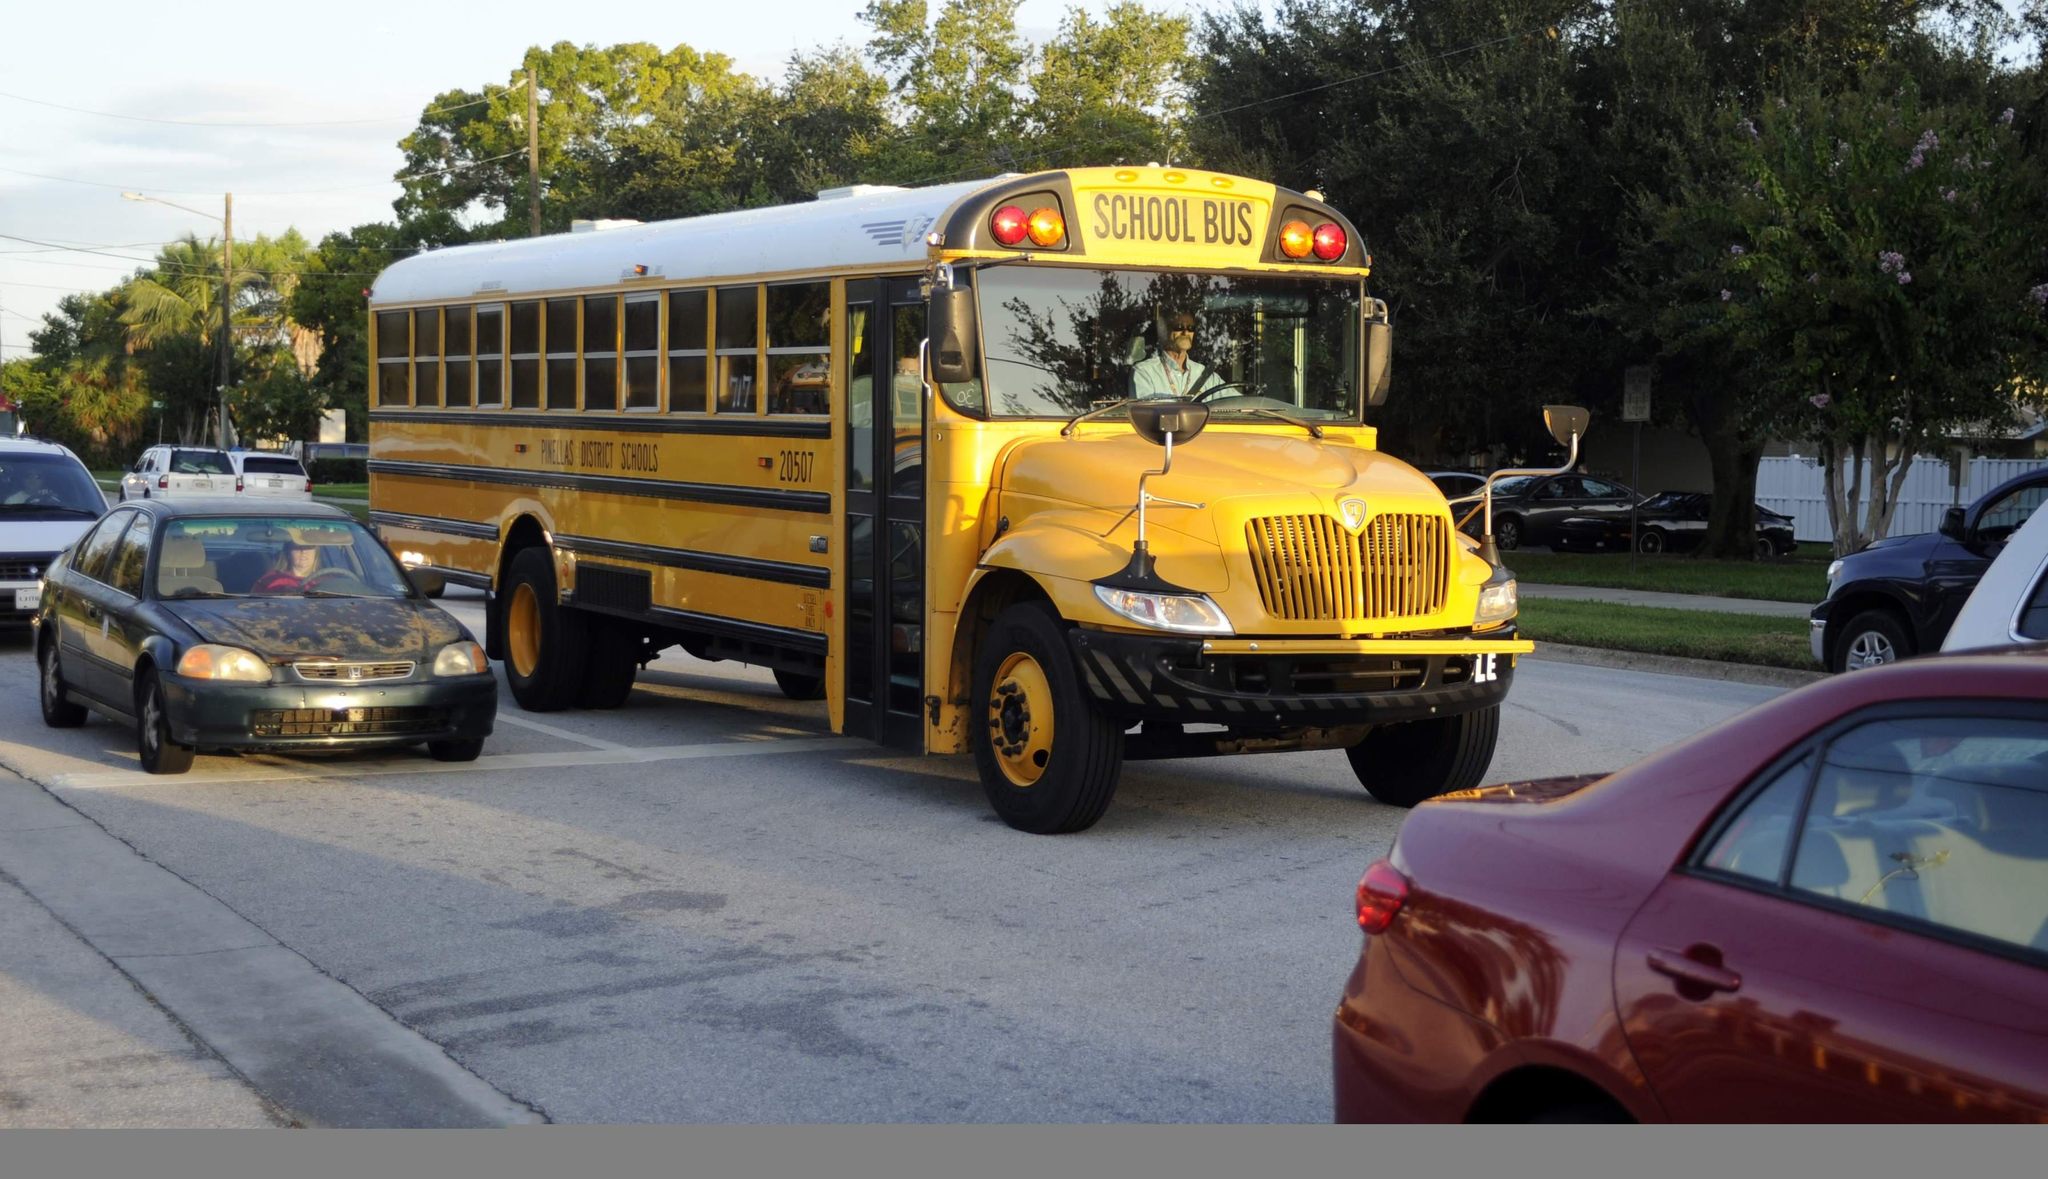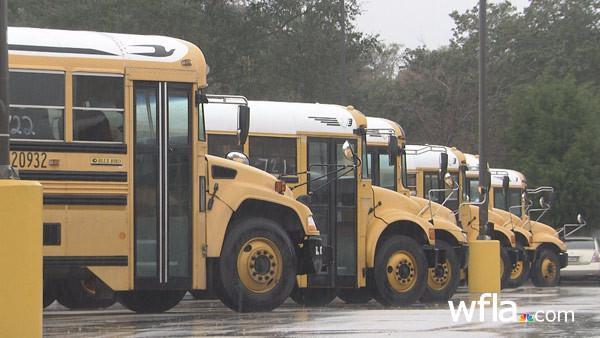The first image is the image on the left, the second image is the image on the right. Examine the images to the left and right. Is the description "One image shows at least five school buses parked next to each other." accurate? Answer yes or no. Yes. The first image is the image on the left, the second image is the image on the right. Considering the images on both sides, is "At least one bus is driving next to other cars." valid? Answer yes or no. Yes. 